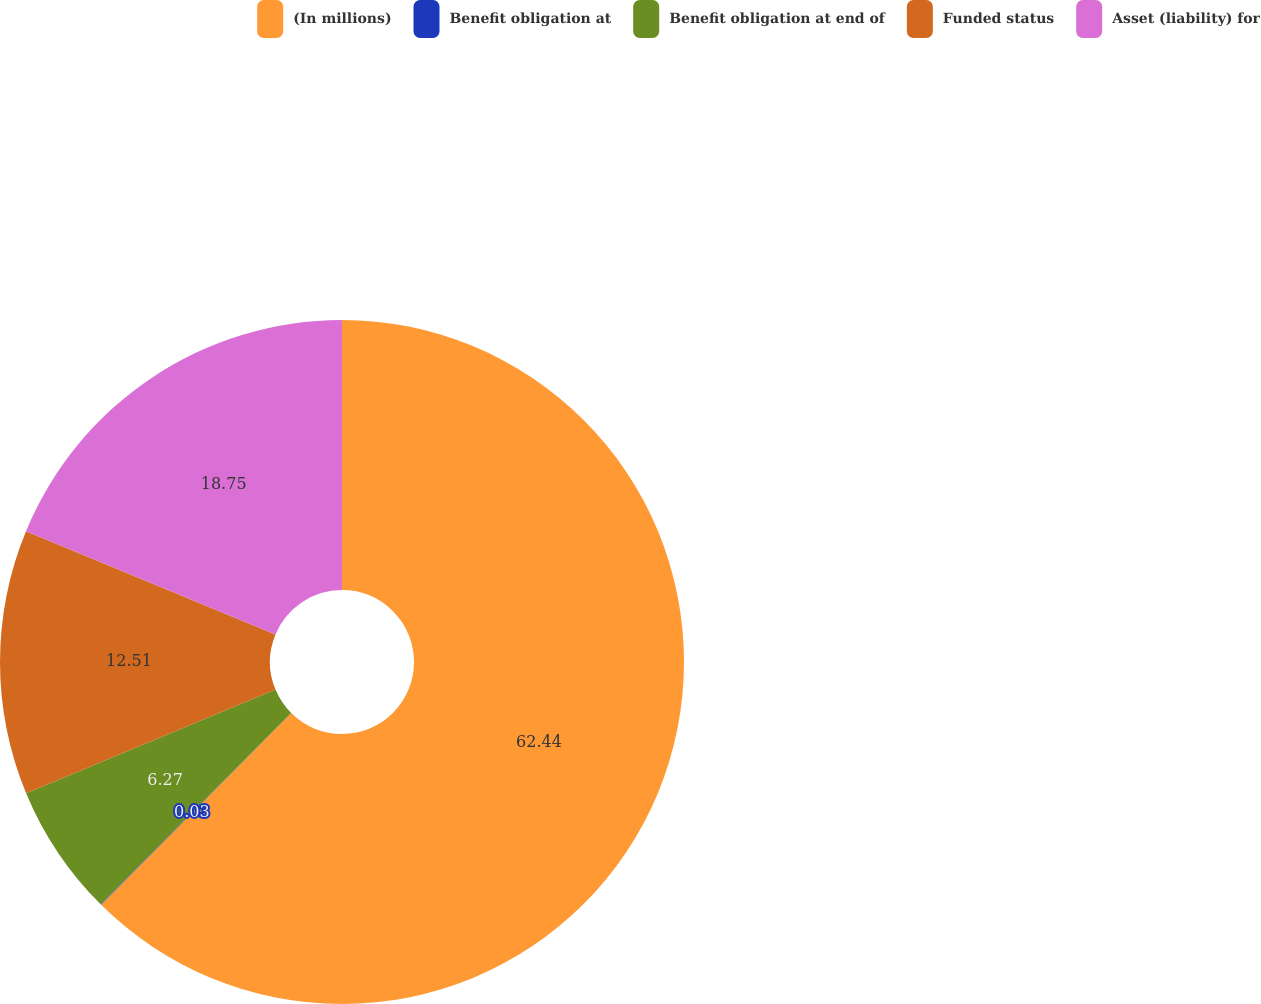Convert chart to OTSL. <chart><loc_0><loc_0><loc_500><loc_500><pie_chart><fcel>(In millions)<fcel>Benefit obligation at<fcel>Benefit obligation at end of<fcel>Funded status<fcel>Asset (liability) for<nl><fcel>62.43%<fcel>0.03%<fcel>6.27%<fcel>12.51%<fcel>18.75%<nl></chart> 